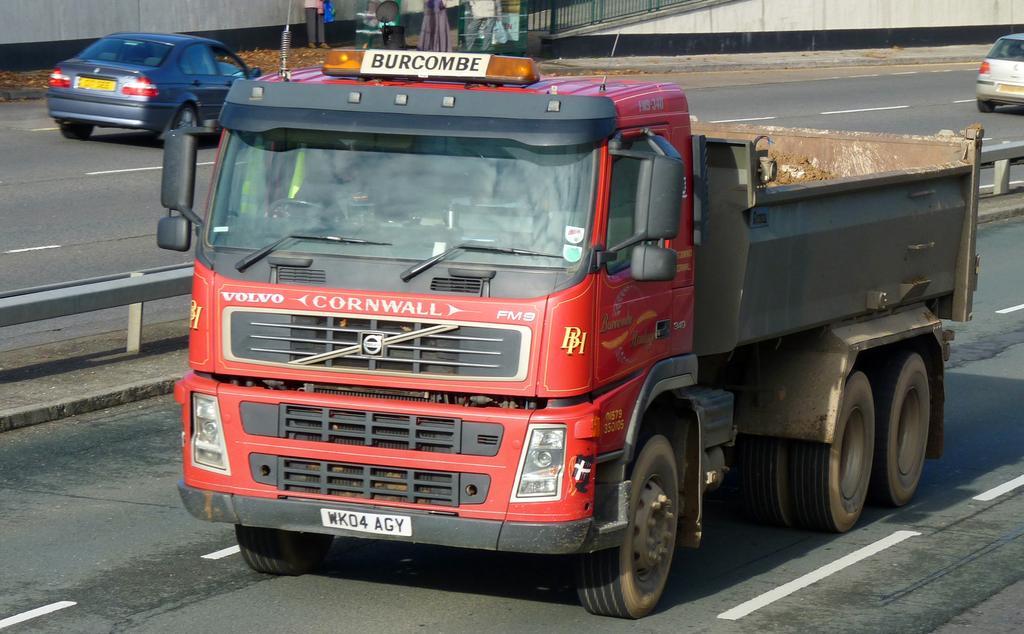Please provide a concise description of this image. In this picture there is a man who is riding a truck. On the other line we can see two cars. At the top there is a man who is standing near to the wall, fencing, gate and pole. On the left side there is a road fencing. 